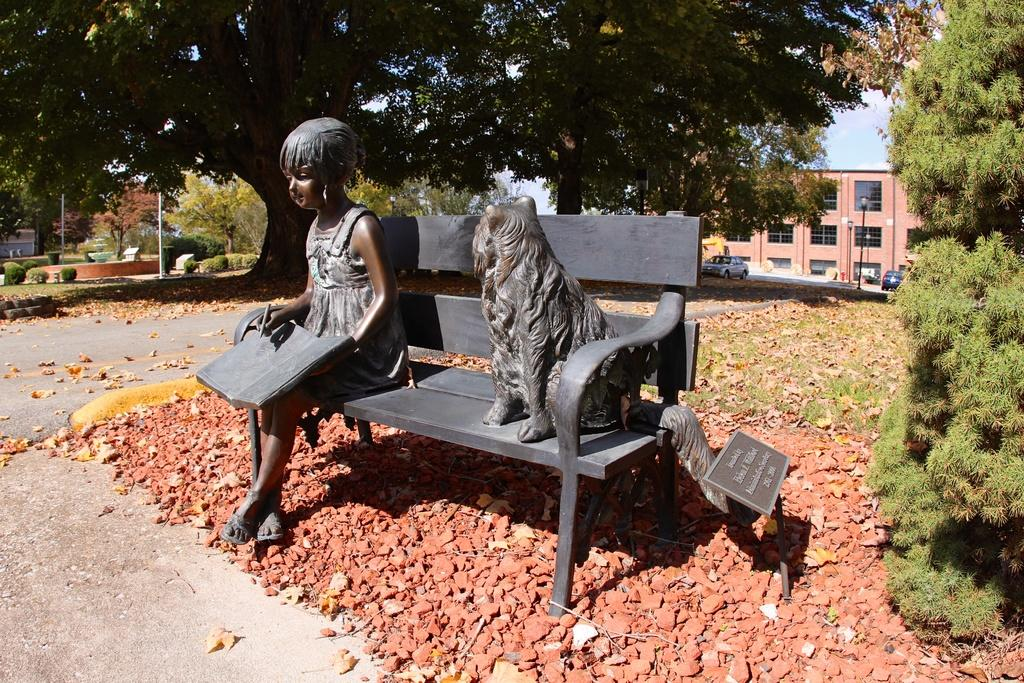What is the main subject of the image? There is an idol of a girl in the image. What is the girl holding in the image? The girl is holding a book. What can be seen on the sofa in the image? There is a dog on the sofa. What is visible in the background of the image? There is a building in the background of the image. What type of vegetation is around the idol? There are plants around the idol. How many ants can be seen carrying a bag in the image? There are no ants or bags present in the image. What type of observation can be made about the girl's behavior in the image? The image is a static representation and does not show any behavior or actions of the girl. 